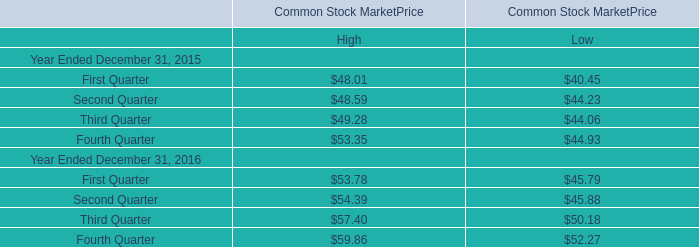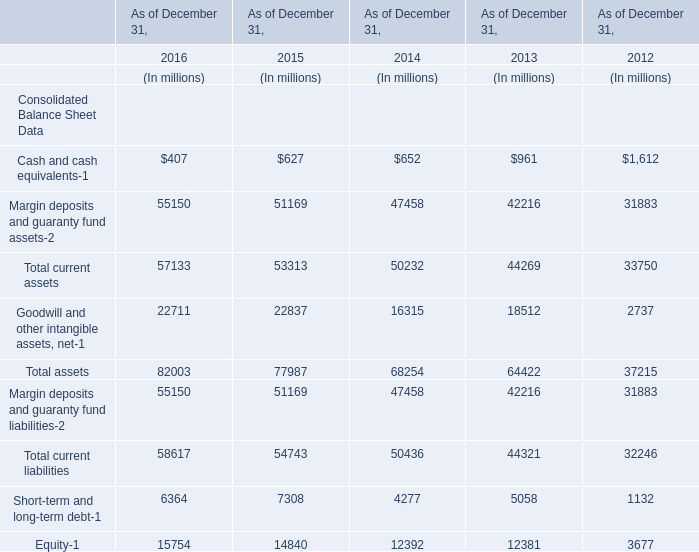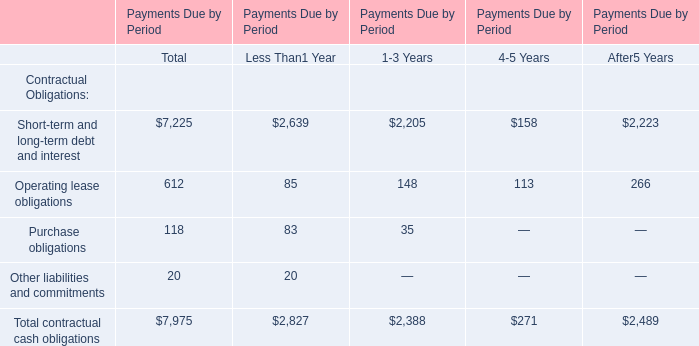What is the ratio of Total current assets for Consolidated Balance Sheet Data to the First Quarter for High for Common Stock MarketPrice in 2015? 
Computations: (53313 / 48.01)
Answer: 1110.45615. 